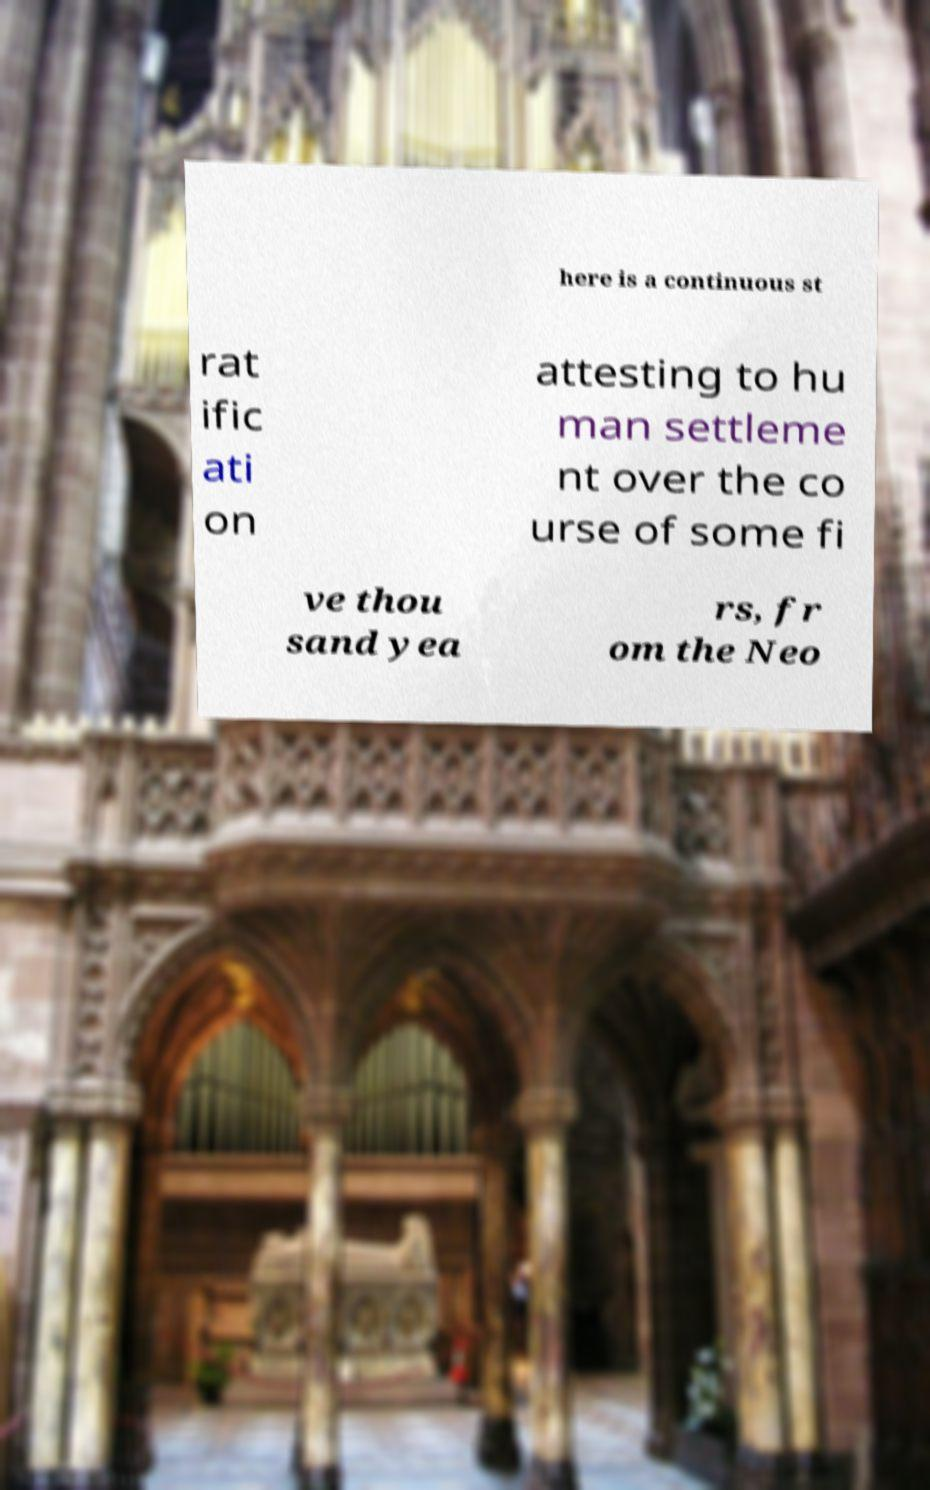There's text embedded in this image that I need extracted. Can you transcribe it verbatim? here is a continuous st rat ific ati on attesting to hu man settleme nt over the co urse of some fi ve thou sand yea rs, fr om the Neo 